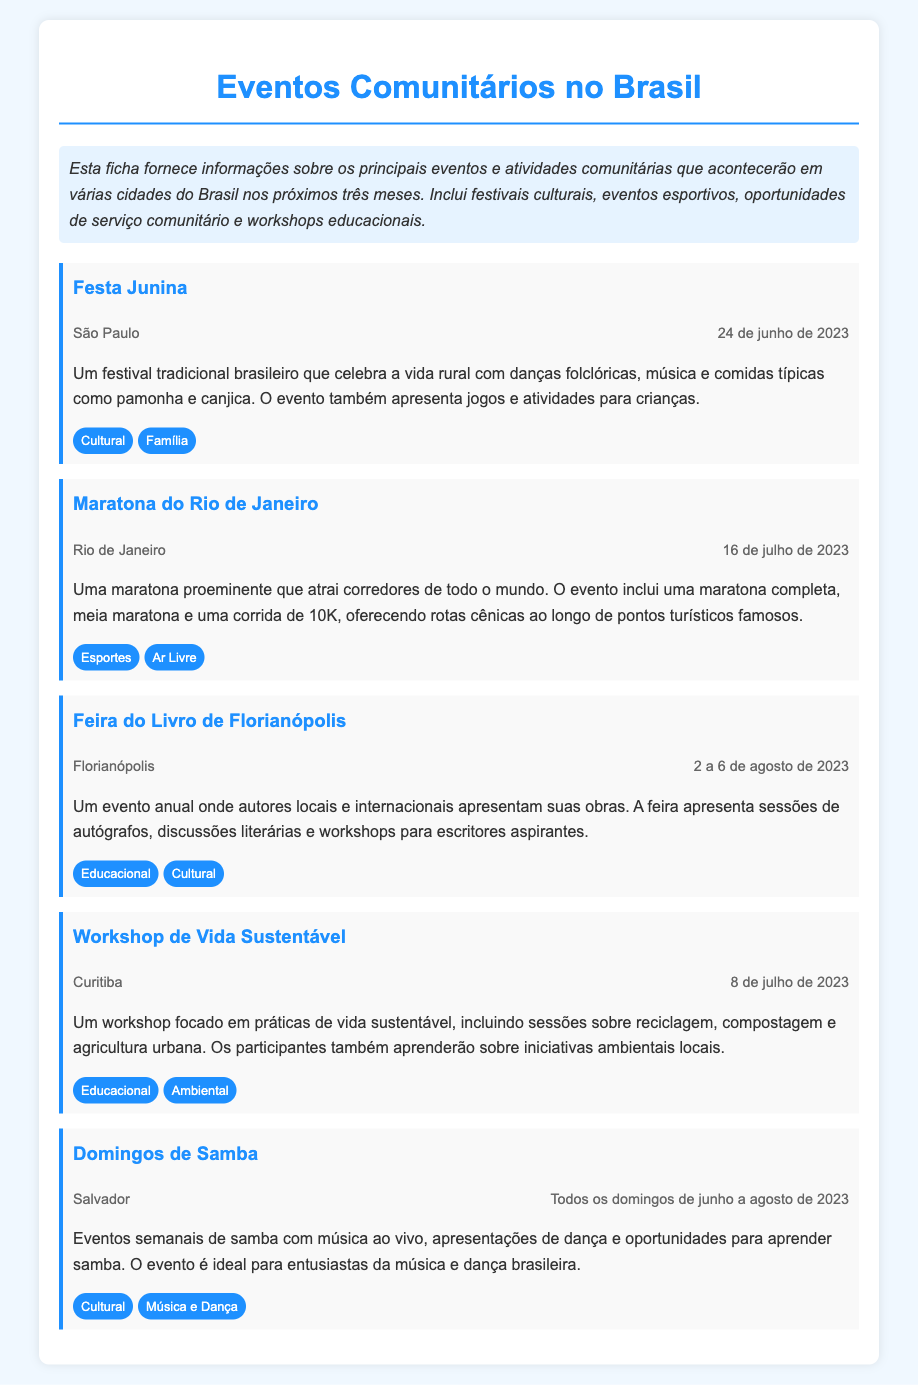Qual é a data da Festa Junina em São Paulo? A Festa Junina ocorrerá no dia 24 de junho de 2023, conforme mencionado no evento.
Answer: 24 de junho de 2023 Qual é a cidade que sediará a Maratona do Rio de Janeiro? A Maratona do Rio de Janeiro acontecerá na cidade do Rio de Janeiro, conforme indicado no documento.
Answer: Rio de Janeiro Quantos dias durará a Feira do Livro de Florianópolis? A Feira do Livro de Florianópolis ocorrerá de 2 a 6 de agosto de 2023, totalizando cinco dias.
Answer: 5 dias Quais são os tipos de eventos listados sob "Domingos de Samba"? Os Domingos de Samba incluem música ao vivo e apresentações de dança, portanto, são eventos culturais e de música e dança.
Answer: Cultural, Música e Dança Qual o foco do Workshop de Vida Sustentável? O Workshop de Vida Sustentável foca em práticas de vida sustentável, como reciclagem e compostagem, de acordo com a descrição do evento.
Answer: Práticas de vida sustentável Quantas categorias estão associadas à Maratona do Rio de Janeiro? A Maratona do Rio de Janeiro possui duas categorias listadas: Esportes e Ar Livre.
Answer: 2 categorias O que é a Festa Junina? A Festa Junina é um festival tradicional brasileiro que celebra a vida rural com danças folclóricas e comidas típicas, conforme descrito no evento.
Answer: Festival tradicional Quais cidades estão mencionadas nos eventos listados? As cidades mencionadas incluem São Paulo, Rio de Janeiro, Florianópolis, Curitiba e Salvador, que são as localidades dos eventos.
Answer: São Paulo, Rio de Janeiro, Florianópolis, Curitiba, Salvador Qual é o tema da Feira do Livro de Florianópolis? O tema da Feira do Livro de Florianópolis gira em torno da literatura, conforme indicado na descrição do evento.
Answer: Literatura 